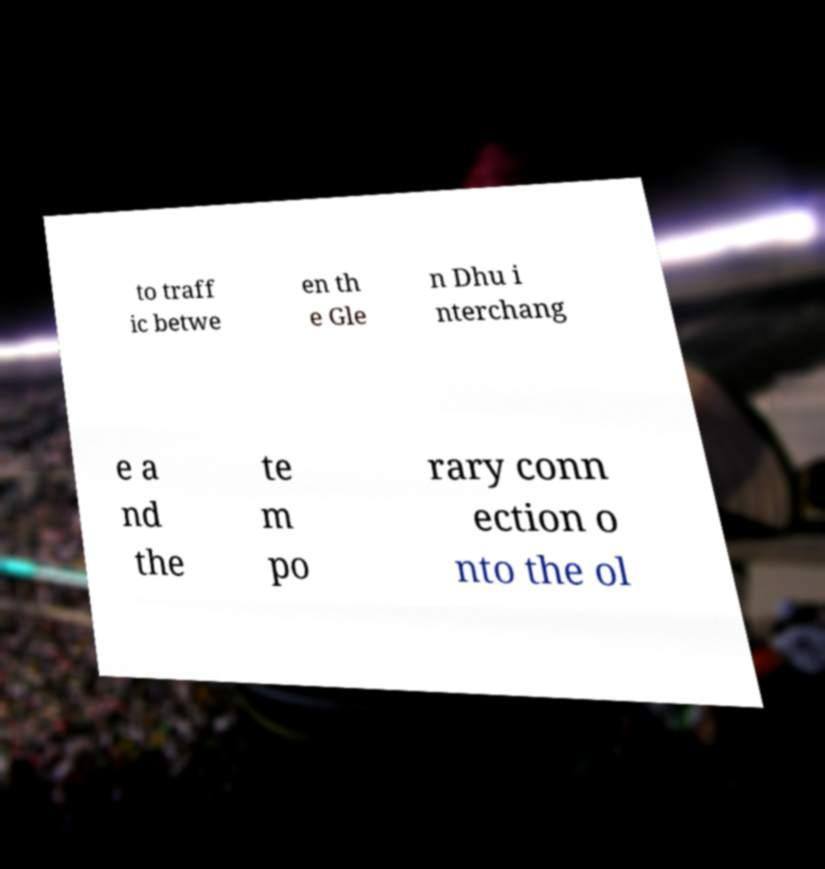Please read and relay the text visible in this image. What does it say? to traff ic betwe en th e Gle n Dhu i nterchang e a nd the te m po rary conn ection o nto the ol 